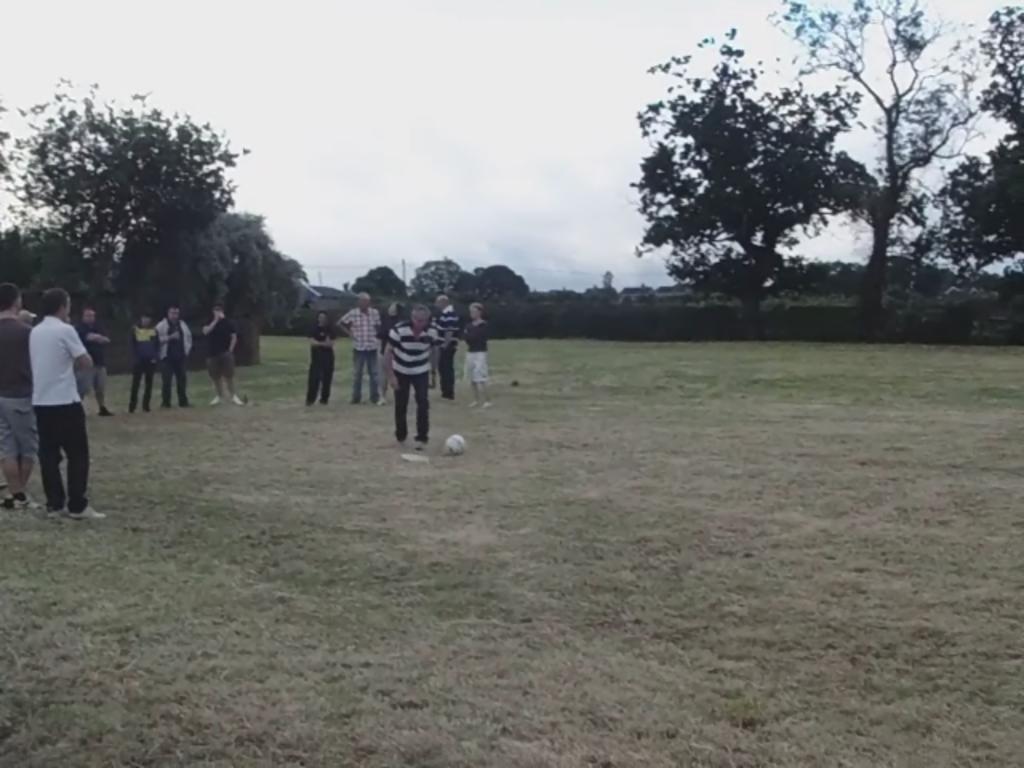Please provide a concise description of this image. In this picture we can see some persons playing football in the ground. Behind there are some trees. 